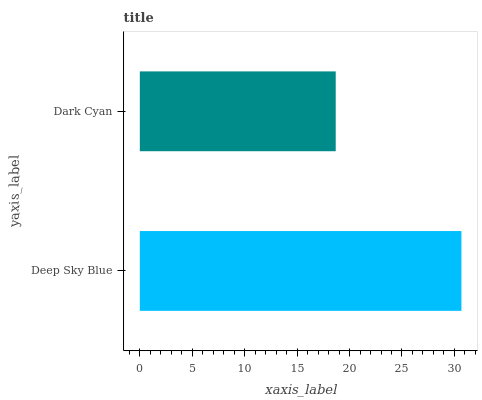Is Dark Cyan the minimum?
Answer yes or no. Yes. Is Deep Sky Blue the maximum?
Answer yes or no. Yes. Is Dark Cyan the maximum?
Answer yes or no. No. Is Deep Sky Blue greater than Dark Cyan?
Answer yes or no. Yes. Is Dark Cyan less than Deep Sky Blue?
Answer yes or no. Yes. Is Dark Cyan greater than Deep Sky Blue?
Answer yes or no. No. Is Deep Sky Blue less than Dark Cyan?
Answer yes or no. No. Is Deep Sky Blue the high median?
Answer yes or no. Yes. Is Dark Cyan the low median?
Answer yes or no. Yes. Is Dark Cyan the high median?
Answer yes or no. No. Is Deep Sky Blue the low median?
Answer yes or no. No. 